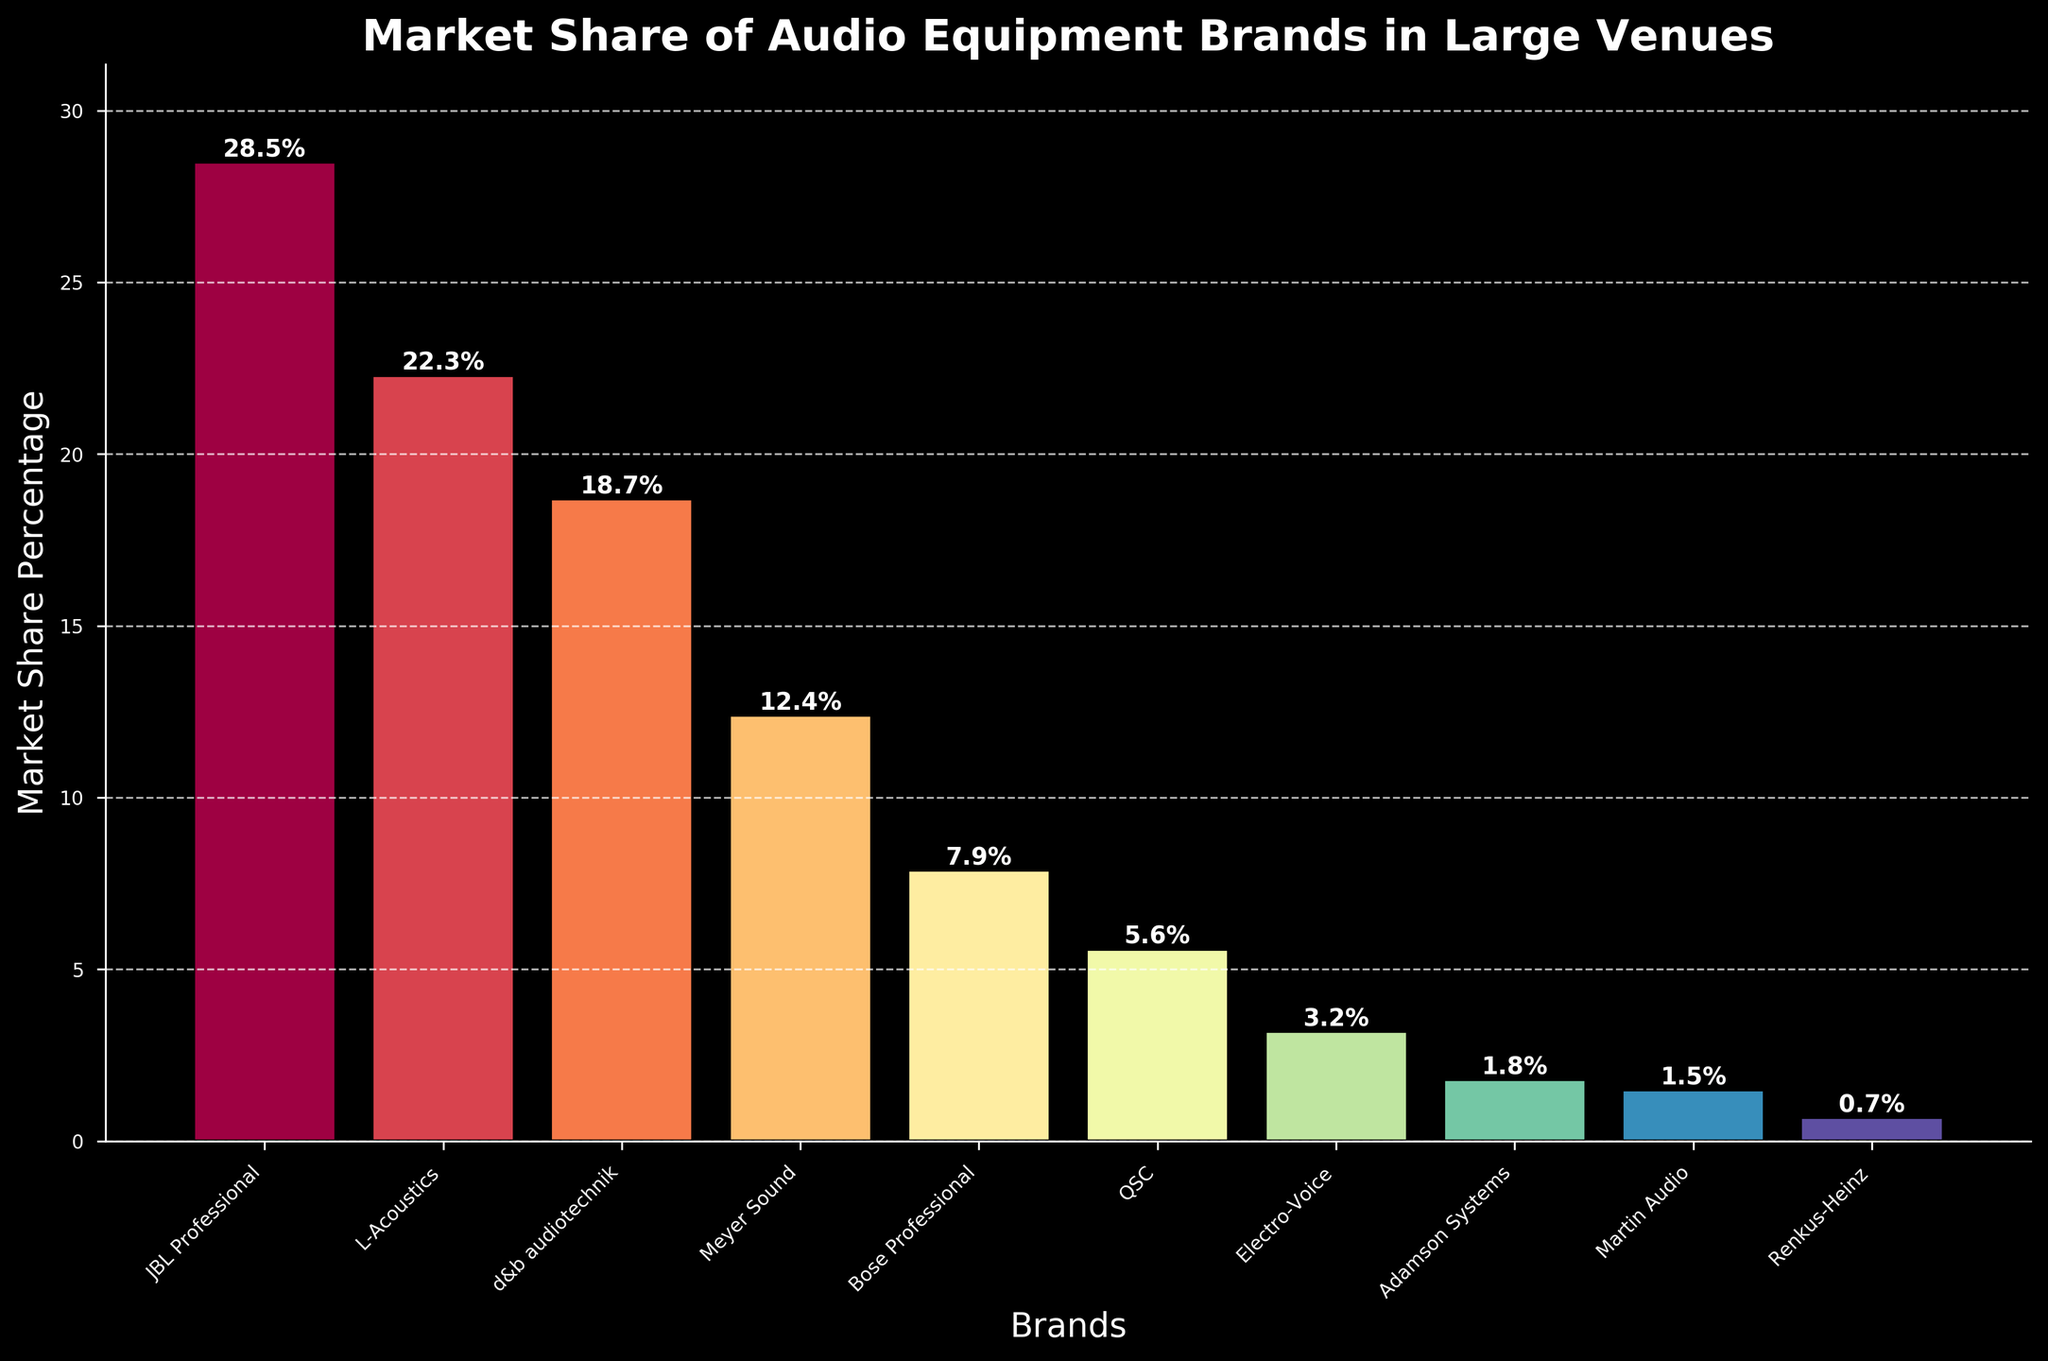What is the market share percentage of the leading brand? The highest bar represents the leading brand, which is JBL Professional. The bar height indicates a market share percentage of 28.5%.
Answer: 28.5% Which brand has the smallest market share? The shortest bar corresponds to the brand Renkus-Heinz, indicating a market share percentage of 0.7%.
Answer: Renkus-Heinz What is the combined market share percentage of the top three brands? The top three brands are JBL Professional (28.5%), L-Acoustics (22.3%), and d&b audiotechnik (18.7%). Adding these gives 28.5 + 22.3 + 18.7 = 69.5%.
Answer: 69.5% How much greater is the market share percentage of L-Acoustics compared to Meyer Sound? L-Acoustics has a market share of 22.3% and Meyer Sound has 12.4%. The difference is 22.3 - 12.4 = 9.9%.
Answer: 9.9% What is the average market share percentage of the bottom five brands? The bottom five brands are QSC (5.6%), Electro-Voice (3.2%), Adamson Systems (1.8%), Martin Audio (1.5%), and Renkus-Heinz (0.7%). Summing these gives 5.6 + 3.2 + 1.8 + 1.5 + 0.7 = 12.8%. The average is 12.8 / 5 = 2.56%.
Answer: 2.56% Which brand has a market share closest to 20%? The brand with a market share percentage close to 20% is L-Acoustics with 22.3%.
Answer: L-Acoustics Is the market share of d&b audiotechnik greater than twice that of Electro-Voice? d&b audiotechnik has a market share of 18.7%, and Electro-Voice has 3.2%. Twice the market share of Electro-Voice is 3.2 * 2 = 6.4%. 18.7% is indeed greater than 6.4%.
Answer: Yes What visual feature is used to indicate the brand names on the x-axis? The brand names are indicated by labels on the x-axis that are rotated at a 45-degree angle to the right.
Answer: Labels rotated at 45 degrees How many brands have a market share percentage below 10%? Counting the bars below 10%, we have Bose Professional (7.9%), QSC (5.6%), Electro-Voice (3.2%), Adamson Systems (1.8%), Martin Audio (1.5%), and Renkus-Heinz (0.7%). This totals to 6 brands.
Answer: 6 brands 